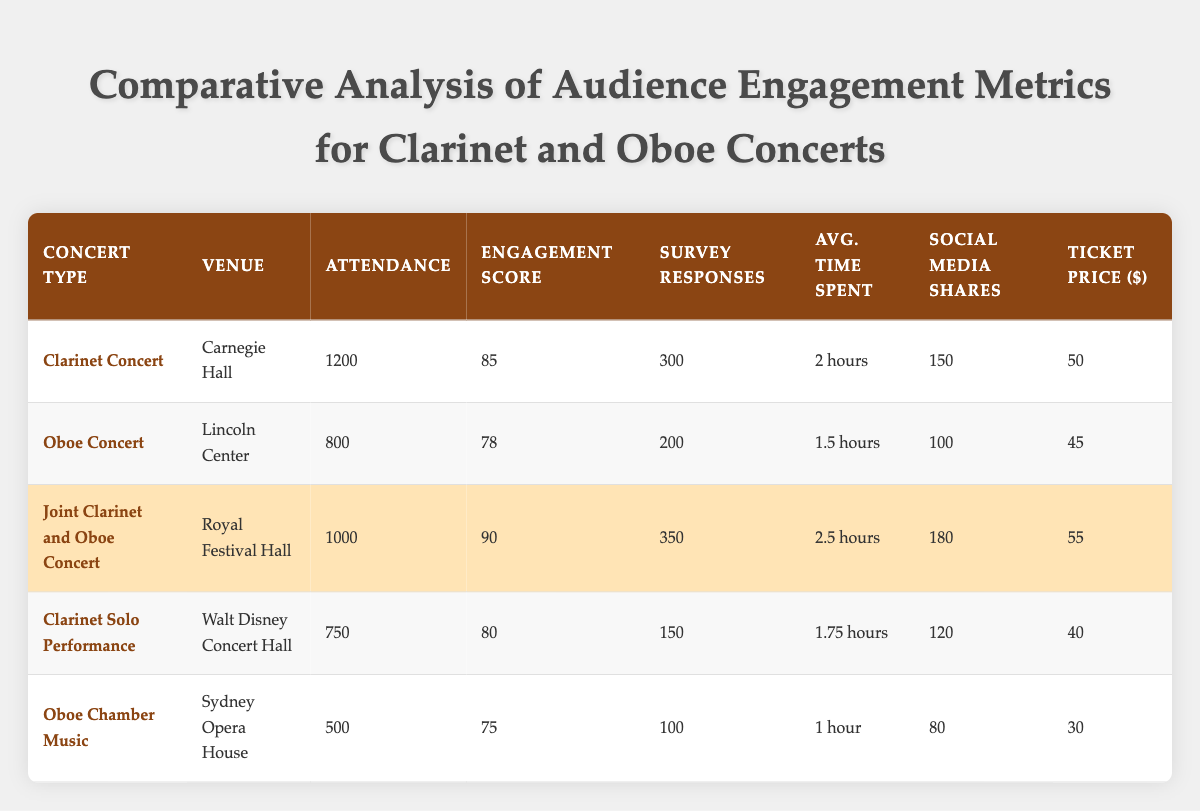What is the venue for the Clarinet Concert? The table lists the venue for each concert type. Looking under the "Concert Type" column for "Clarinet Concert," I see that the corresponding venue listed is "Carnegie Hall."
Answer: Carnegie Hall What is the engagement score for the Oboe Concert? Referring to the Oboe Concert row, the engagement score is located in the "Engagement Score" column, which displays a score of 78.
Answer: 78 Which concert had the highest attendance? To find which concert had the highest attendance, I compare the attendance figures from all the concert rows. The Clarinet Concert at Carnegie Hall shows the highest attendance at 1200 people.
Answer: 1200 What is the average ticket price for the Clarinet-related concerts? The ticket prices for Clarinet concerts in the table are for the Clarinet Concert ($50), Joint Clarinet and Oboe Concert ($55), and Clarinet Solo Performance ($40). Adding these amounts gives a total of $50 + $55 + $40 = $145. Dividing by the number of concerts (3) gives an average ticket price of 145/3 = 48.33.
Answer: 48.33 Does the Joint Clarinet and Oboe Concert have more social media shares than the Oboe Chamber Music? By looking at the "Social Media Shares" column, the Joint Clarinet and Oboe Concert has 180 shares, while the Oboe Chamber Music has 80 shares. Since 180 is greater than 80, the statement is true.
Answer: Yes How long, on average, do attendees spend at Oboe concerts compared to Clarinet concerts? The average time spent at the Oboe Concert is 1.5 hours, while the average time for the Clarinet Concert is 2 hours. To find the average, I would use both values: (1.5 + 2) / 2 = 1.75 hours for both types combined. Additionally, comparing them shows that Clarinet concert attendees spend more time overall.
Answer: Clarinet concerts average 2 hours, Oboe concerts average 1.5 hours What is the difference in engagement score between Joint Clarinet and Oboe Concert and the Oboe Chamber Music? The engagement score for the Joint Clarinet and Oboe Concert is 90, and for the Oboe Chamber Music, it is 75. To find the difference, I subtract: 90 - 75 = 15. Thus, the difference is 15.
Answer: 15 Which concert had the least number of post-concert survey responses? To determine which concert had the least survey responses, I compare the numbers listed in the "Survey Responses" column. The Oboe Chamber Music has the lowest with 100 responses.
Answer: Oboe Chamber Music Was the attendance for the Joint Concert higher than that of the Clarinet Solo Performance? The attendance for the Joint Clarinet and Oboe Concert is 1000, and for the Clarinet Solo Performance, it is 750. Since 1000 is greater than 750, the statement is true.
Answer: Yes 